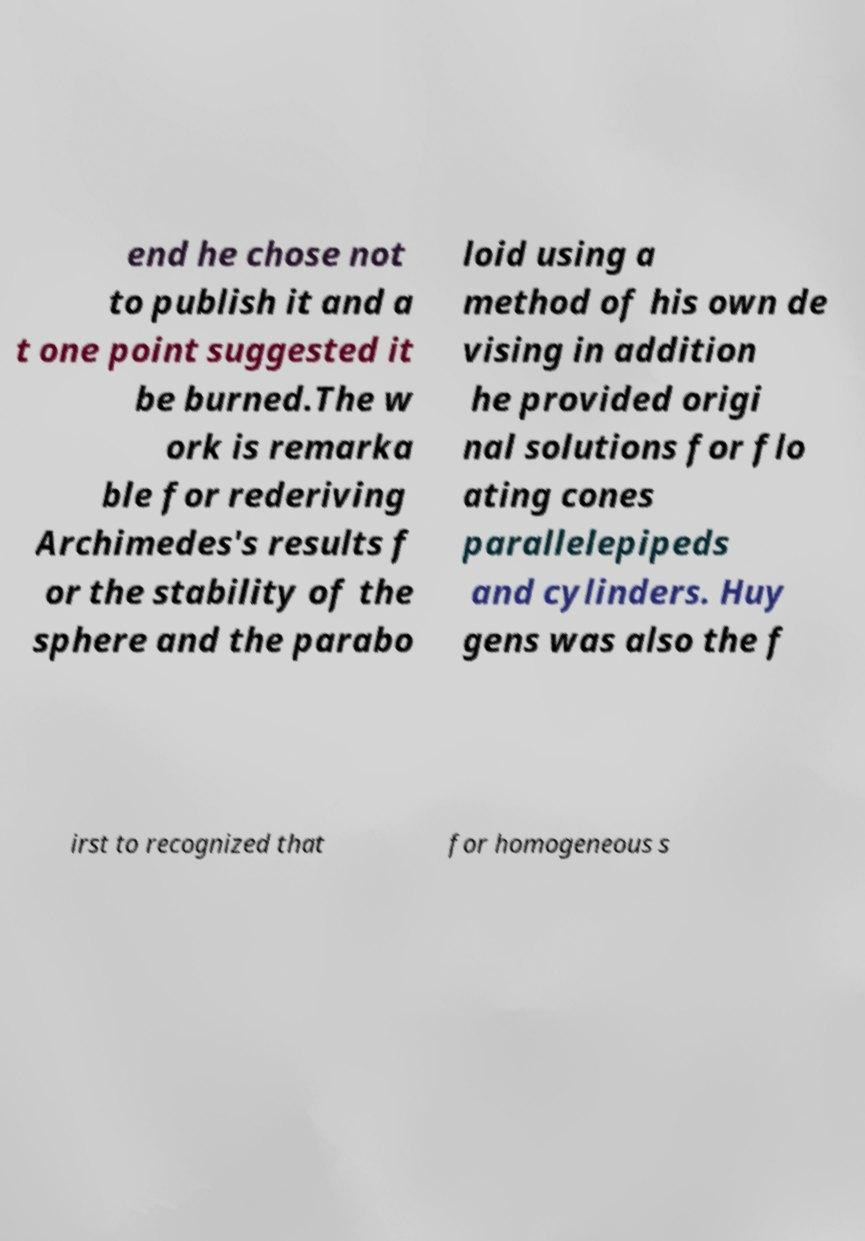Please read and relay the text visible in this image. What does it say? end he chose not to publish it and a t one point suggested it be burned.The w ork is remarka ble for rederiving Archimedes's results f or the stability of the sphere and the parabo loid using a method of his own de vising in addition he provided origi nal solutions for flo ating cones parallelepipeds and cylinders. Huy gens was also the f irst to recognized that for homogeneous s 